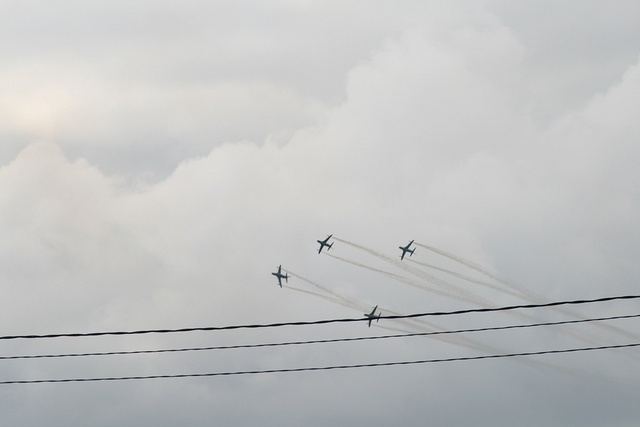Describe the objects in this image and their specific colors. I can see airplane in lightgray, darkgray, black, gray, and purple tones, airplane in lightgray, gray, darkgray, black, and purple tones, airplane in lightgray, gray, darkgray, purple, and darkblue tones, and airplane in lightgray, black, gray, darkgray, and purple tones in this image. 